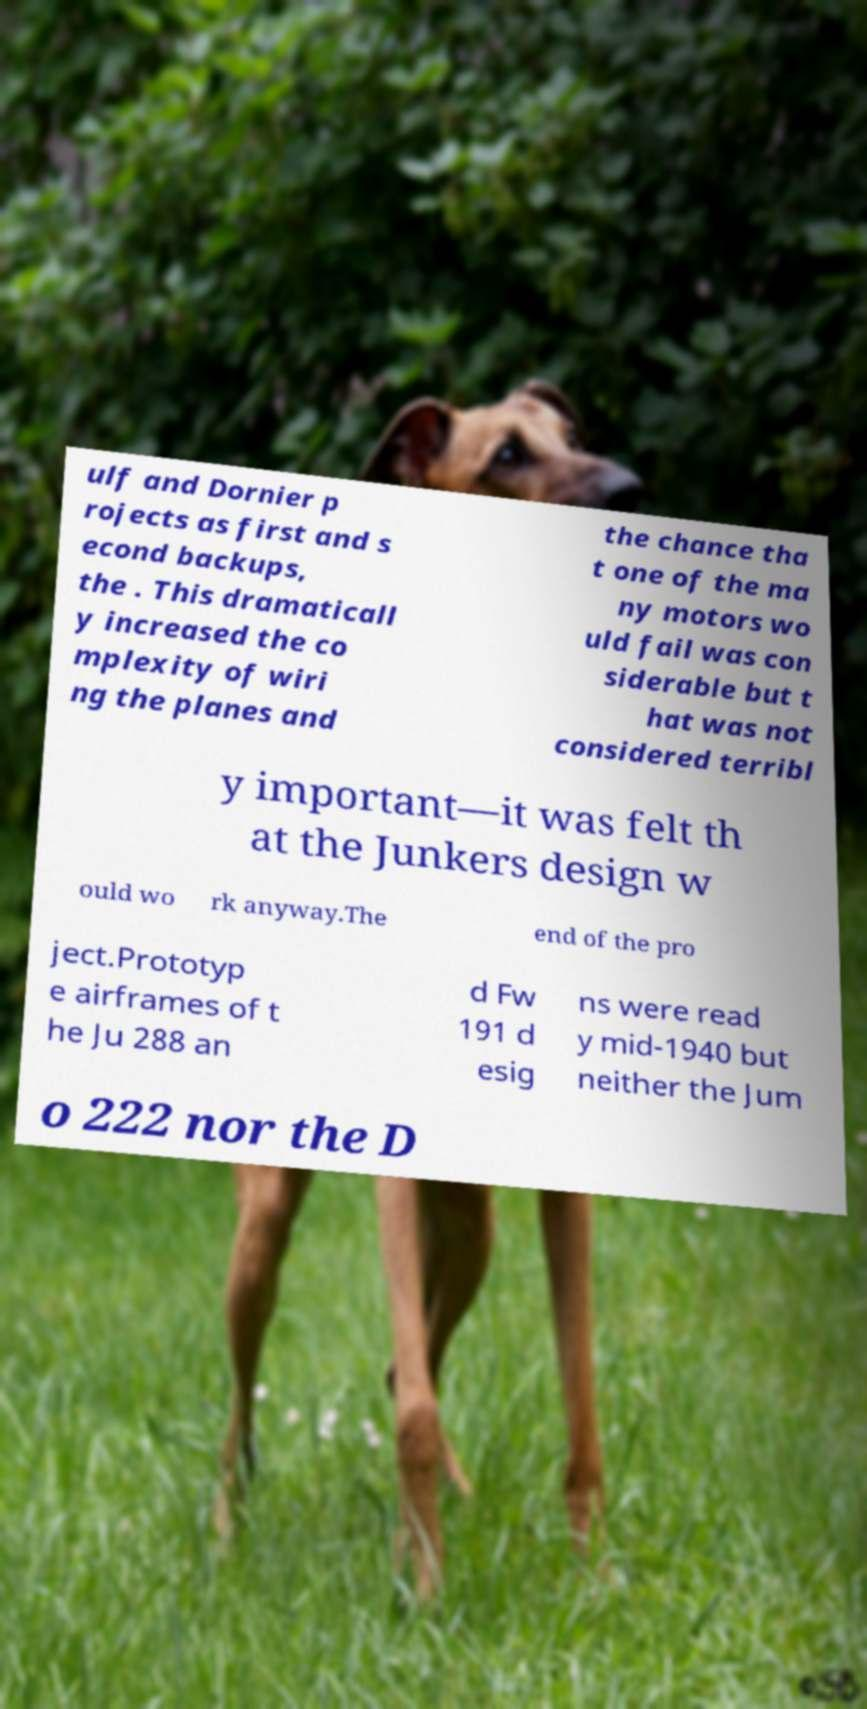Please identify and transcribe the text found in this image. ulf and Dornier p rojects as first and s econd backups, the . This dramaticall y increased the co mplexity of wiri ng the planes and the chance tha t one of the ma ny motors wo uld fail was con siderable but t hat was not considered terribl y important—it was felt th at the Junkers design w ould wo rk anyway.The end of the pro ject.Prototyp e airframes of t he Ju 288 an d Fw 191 d esig ns were read y mid-1940 but neither the Jum o 222 nor the D 